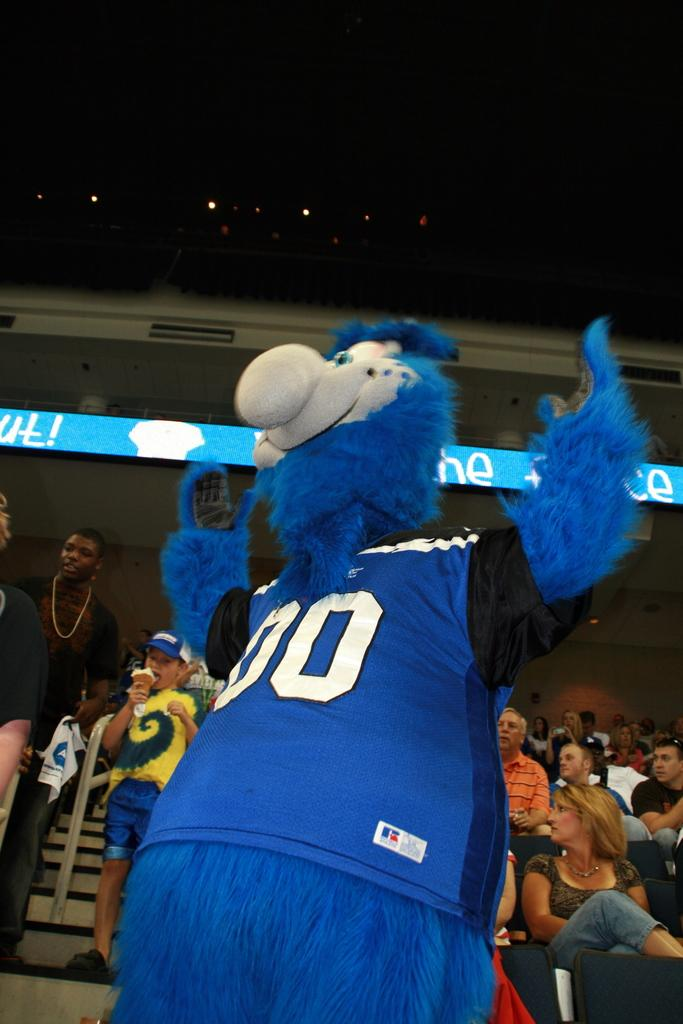What is the main subject of the image? There is a man in the image. What is the man wearing? The man is wearing a costume. What is the man's posture in the image? The man is standing. Can you describe the people in the background of the image? Some people in the background are sitting on chairs, while others are standing. What type of apple is being exchanged between the children in the image? There are no children or apples present in the image. What type of costume is the man wearing in the image? The provided facts do not specify the type of costume the man is wearing. 